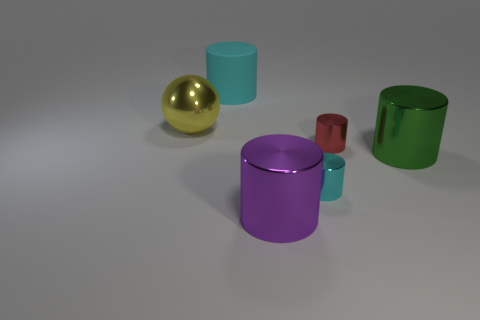There is another object that is the same color as the big rubber object; what is it made of?
Keep it short and to the point. Metal. Does the cyan rubber object have the same shape as the yellow metal object?
Keep it short and to the point. No. Are there fewer tiny things that are to the right of the large green cylinder than large cylinders?
Your answer should be compact. Yes. There is a large cylinder in front of the cyan object in front of the large thing on the right side of the purple metal cylinder; what color is it?
Make the answer very short. Purple. What number of metal objects are either cyan cylinders or large purple cubes?
Provide a succinct answer. 1. Do the purple cylinder and the red thing have the same size?
Provide a succinct answer. No. Are there fewer big shiny objects behind the big green shiny thing than matte things in front of the big purple metal thing?
Keep it short and to the point. No. Is there anything else that has the same size as the red cylinder?
Ensure brevity in your answer.  Yes. How big is the yellow object?
Your answer should be compact. Large. How many large objects are either purple objects or yellow shiny spheres?
Your answer should be compact. 2. 